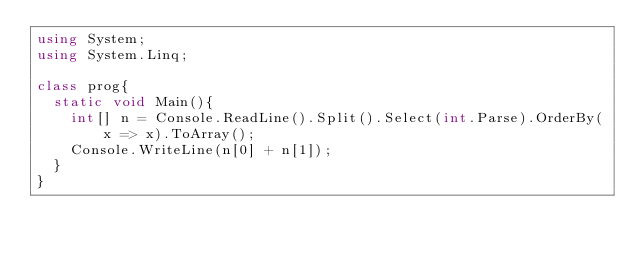Convert code to text. <code><loc_0><loc_0><loc_500><loc_500><_C#_>using System;
using System.Linq;

class prog{
  static void Main(){
    int[] n = Console.ReadLine().Split().Select(int.Parse).OrderBy(x => x).ToArray();
    Console.WriteLine(n[0] + n[1]);
  }
}
    </code> 